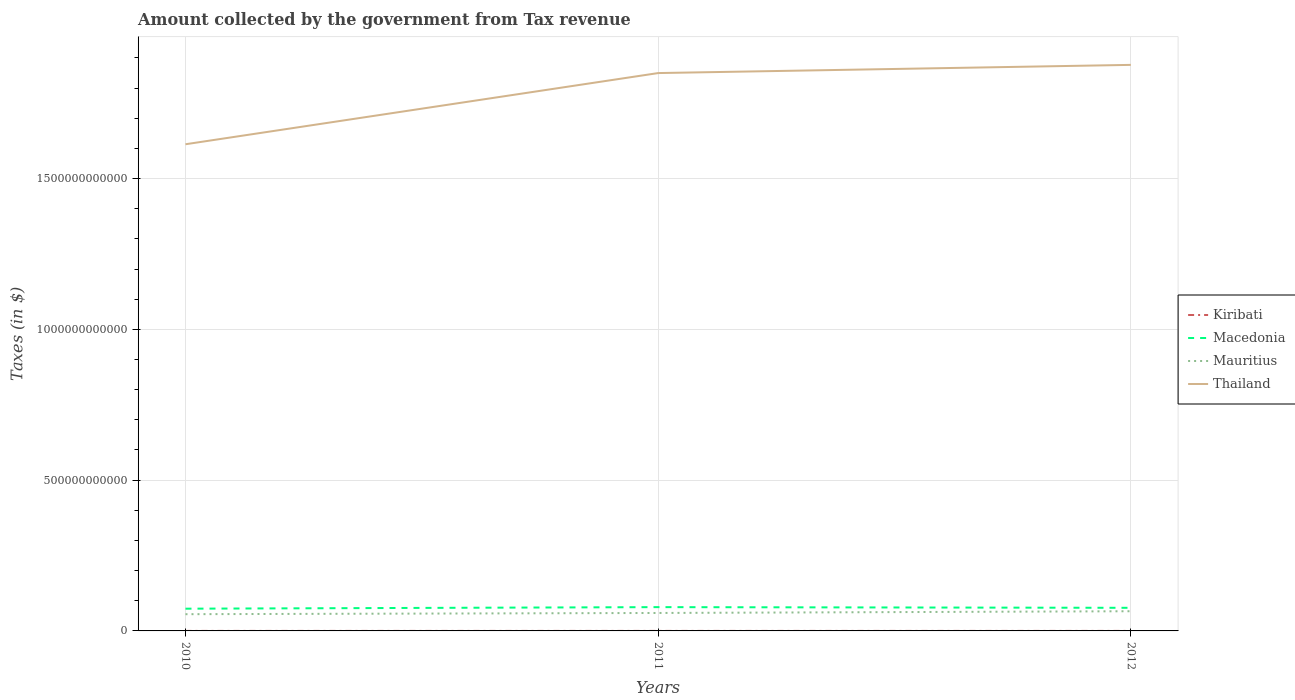How many different coloured lines are there?
Make the answer very short. 4. Does the line corresponding to Kiribati intersect with the line corresponding to Macedonia?
Offer a terse response. No. Is the number of lines equal to the number of legend labels?
Make the answer very short. Yes. Across all years, what is the maximum amount collected by the government from tax revenue in Mauritius?
Your response must be concise. 5.55e+1. What is the total amount collected by the government from tax revenue in Kiribati in the graph?
Keep it short and to the point. -5.32e+05. What is the difference between the highest and the second highest amount collected by the government from tax revenue in Thailand?
Ensure brevity in your answer.  2.63e+11. Is the amount collected by the government from tax revenue in Thailand strictly greater than the amount collected by the government from tax revenue in Macedonia over the years?
Offer a terse response. No. How many years are there in the graph?
Offer a very short reply. 3. What is the difference between two consecutive major ticks on the Y-axis?
Offer a very short reply. 5.00e+11. Are the values on the major ticks of Y-axis written in scientific E-notation?
Your answer should be very brief. No. Does the graph contain any zero values?
Your answer should be compact. No. Where does the legend appear in the graph?
Provide a short and direct response. Center right. How many legend labels are there?
Provide a succinct answer. 4. What is the title of the graph?
Your answer should be very brief. Amount collected by the government from Tax revenue. What is the label or title of the X-axis?
Give a very brief answer. Years. What is the label or title of the Y-axis?
Offer a very short reply. Taxes (in $). What is the Taxes (in $) of Kiribati in 2010?
Keep it short and to the point. 2.67e+07. What is the Taxes (in $) of Macedonia in 2010?
Provide a succinct answer. 7.38e+1. What is the Taxes (in $) of Mauritius in 2010?
Ensure brevity in your answer.  5.55e+1. What is the Taxes (in $) of Thailand in 2010?
Your response must be concise. 1.61e+12. What is the Taxes (in $) of Kiribati in 2011?
Your response must be concise. 2.73e+07. What is the Taxes (in $) in Macedonia in 2011?
Keep it short and to the point. 7.89e+1. What is the Taxes (in $) in Mauritius in 2011?
Make the answer very short. 5.95e+1. What is the Taxes (in $) in Thailand in 2011?
Give a very brief answer. 1.85e+12. What is the Taxes (in $) of Kiribati in 2012?
Give a very brief answer. 2.71e+07. What is the Taxes (in $) in Macedonia in 2012?
Your answer should be compact. 7.66e+1. What is the Taxes (in $) of Mauritius in 2012?
Provide a short and direct response. 6.53e+1. What is the Taxes (in $) in Thailand in 2012?
Keep it short and to the point. 1.88e+12. Across all years, what is the maximum Taxes (in $) in Kiribati?
Ensure brevity in your answer.  2.73e+07. Across all years, what is the maximum Taxes (in $) of Macedonia?
Offer a very short reply. 7.89e+1. Across all years, what is the maximum Taxes (in $) in Mauritius?
Provide a short and direct response. 6.53e+1. Across all years, what is the maximum Taxes (in $) of Thailand?
Keep it short and to the point. 1.88e+12. Across all years, what is the minimum Taxes (in $) of Kiribati?
Give a very brief answer. 2.67e+07. Across all years, what is the minimum Taxes (in $) in Macedonia?
Provide a succinct answer. 7.38e+1. Across all years, what is the minimum Taxes (in $) in Mauritius?
Your answer should be compact. 5.55e+1. Across all years, what is the minimum Taxes (in $) in Thailand?
Make the answer very short. 1.61e+12. What is the total Taxes (in $) of Kiribati in the graph?
Keep it short and to the point. 8.11e+07. What is the total Taxes (in $) in Macedonia in the graph?
Offer a terse response. 2.29e+11. What is the total Taxes (in $) in Mauritius in the graph?
Give a very brief answer. 1.80e+11. What is the total Taxes (in $) of Thailand in the graph?
Ensure brevity in your answer.  5.34e+12. What is the difference between the Taxes (in $) in Kiribati in 2010 and that in 2011?
Your answer should be compact. -5.32e+05. What is the difference between the Taxes (in $) of Macedonia in 2010 and that in 2011?
Offer a very short reply. -5.16e+09. What is the difference between the Taxes (in $) in Mauritius in 2010 and that in 2011?
Your response must be concise. -4.05e+09. What is the difference between the Taxes (in $) in Thailand in 2010 and that in 2011?
Offer a terse response. -2.36e+11. What is the difference between the Taxes (in $) in Kiribati in 2010 and that in 2012?
Offer a very short reply. -3.91e+05. What is the difference between the Taxes (in $) of Macedonia in 2010 and that in 2012?
Your answer should be very brief. -2.86e+09. What is the difference between the Taxes (in $) in Mauritius in 2010 and that in 2012?
Ensure brevity in your answer.  -9.81e+09. What is the difference between the Taxes (in $) in Thailand in 2010 and that in 2012?
Keep it short and to the point. -2.63e+11. What is the difference between the Taxes (in $) of Kiribati in 2011 and that in 2012?
Ensure brevity in your answer.  1.41e+05. What is the difference between the Taxes (in $) in Macedonia in 2011 and that in 2012?
Your answer should be very brief. 2.29e+09. What is the difference between the Taxes (in $) of Mauritius in 2011 and that in 2012?
Provide a short and direct response. -5.76e+09. What is the difference between the Taxes (in $) in Thailand in 2011 and that in 2012?
Your response must be concise. -2.72e+1. What is the difference between the Taxes (in $) of Kiribati in 2010 and the Taxes (in $) of Macedonia in 2011?
Provide a succinct answer. -7.89e+1. What is the difference between the Taxes (in $) of Kiribati in 2010 and the Taxes (in $) of Mauritius in 2011?
Give a very brief answer. -5.95e+1. What is the difference between the Taxes (in $) of Kiribati in 2010 and the Taxes (in $) of Thailand in 2011?
Ensure brevity in your answer.  -1.85e+12. What is the difference between the Taxes (in $) of Macedonia in 2010 and the Taxes (in $) of Mauritius in 2011?
Make the answer very short. 1.42e+1. What is the difference between the Taxes (in $) of Macedonia in 2010 and the Taxes (in $) of Thailand in 2011?
Provide a short and direct response. -1.78e+12. What is the difference between the Taxes (in $) of Mauritius in 2010 and the Taxes (in $) of Thailand in 2011?
Offer a very short reply. -1.79e+12. What is the difference between the Taxes (in $) of Kiribati in 2010 and the Taxes (in $) of Macedonia in 2012?
Provide a succinct answer. -7.66e+1. What is the difference between the Taxes (in $) in Kiribati in 2010 and the Taxes (in $) in Mauritius in 2012?
Your answer should be very brief. -6.53e+1. What is the difference between the Taxes (in $) in Kiribati in 2010 and the Taxes (in $) in Thailand in 2012?
Make the answer very short. -1.88e+12. What is the difference between the Taxes (in $) of Macedonia in 2010 and the Taxes (in $) of Mauritius in 2012?
Make the answer very short. 8.46e+09. What is the difference between the Taxes (in $) in Macedonia in 2010 and the Taxes (in $) in Thailand in 2012?
Offer a terse response. -1.80e+12. What is the difference between the Taxes (in $) of Mauritius in 2010 and the Taxes (in $) of Thailand in 2012?
Keep it short and to the point. -1.82e+12. What is the difference between the Taxes (in $) of Kiribati in 2011 and the Taxes (in $) of Macedonia in 2012?
Provide a short and direct response. -7.66e+1. What is the difference between the Taxes (in $) of Kiribati in 2011 and the Taxes (in $) of Mauritius in 2012?
Ensure brevity in your answer.  -6.53e+1. What is the difference between the Taxes (in $) of Kiribati in 2011 and the Taxes (in $) of Thailand in 2012?
Ensure brevity in your answer.  -1.88e+12. What is the difference between the Taxes (in $) in Macedonia in 2011 and the Taxes (in $) in Mauritius in 2012?
Give a very brief answer. 1.36e+1. What is the difference between the Taxes (in $) of Macedonia in 2011 and the Taxes (in $) of Thailand in 2012?
Offer a very short reply. -1.80e+12. What is the difference between the Taxes (in $) in Mauritius in 2011 and the Taxes (in $) in Thailand in 2012?
Your answer should be compact. -1.82e+12. What is the average Taxes (in $) of Kiribati per year?
Give a very brief answer. 2.70e+07. What is the average Taxes (in $) of Macedonia per year?
Make the answer very short. 7.64e+1. What is the average Taxes (in $) of Mauritius per year?
Your response must be concise. 6.01e+1. What is the average Taxes (in $) of Thailand per year?
Your answer should be compact. 1.78e+12. In the year 2010, what is the difference between the Taxes (in $) in Kiribati and Taxes (in $) in Macedonia?
Your answer should be very brief. -7.37e+1. In the year 2010, what is the difference between the Taxes (in $) of Kiribati and Taxes (in $) of Mauritius?
Ensure brevity in your answer.  -5.55e+1. In the year 2010, what is the difference between the Taxes (in $) of Kiribati and Taxes (in $) of Thailand?
Make the answer very short. -1.61e+12. In the year 2010, what is the difference between the Taxes (in $) of Macedonia and Taxes (in $) of Mauritius?
Offer a very short reply. 1.83e+1. In the year 2010, what is the difference between the Taxes (in $) in Macedonia and Taxes (in $) in Thailand?
Offer a very short reply. -1.54e+12. In the year 2010, what is the difference between the Taxes (in $) in Mauritius and Taxes (in $) in Thailand?
Your answer should be very brief. -1.56e+12. In the year 2011, what is the difference between the Taxes (in $) in Kiribati and Taxes (in $) in Macedonia?
Provide a succinct answer. -7.89e+1. In the year 2011, what is the difference between the Taxes (in $) in Kiribati and Taxes (in $) in Mauritius?
Ensure brevity in your answer.  -5.95e+1. In the year 2011, what is the difference between the Taxes (in $) of Kiribati and Taxes (in $) of Thailand?
Keep it short and to the point. -1.85e+12. In the year 2011, what is the difference between the Taxes (in $) of Macedonia and Taxes (in $) of Mauritius?
Keep it short and to the point. 1.94e+1. In the year 2011, what is the difference between the Taxes (in $) of Macedonia and Taxes (in $) of Thailand?
Make the answer very short. -1.77e+12. In the year 2011, what is the difference between the Taxes (in $) of Mauritius and Taxes (in $) of Thailand?
Give a very brief answer. -1.79e+12. In the year 2012, what is the difference between the Taxes (in $) of Kiribati and Taxes (in $) of Macedonia?
Keep it short and to the point. -7.66e+1. In the year 2012, what is the difference between the Taxes (in $) of Kiribati and Taxes (in $) of Mauritius?
Your response must be concise. -6.53e+1. In the year 2012, what is the difference between the Taxes (in $) of Kiribati and Taxes (in $) of Thailand?
Your response must be concise. -1.88e+12. In the year 2012, what is the difference between the Taxes (in $) in Macedonia and Taxes (in $) in Mauritius?
Give a very brief answer. 1.13e+1. In the year 2012, what is the difference between the Taxes (in $) in Macedonia and Taxes (in $) in Thailand?
Offer a terse response. -1.80e+12. In the year 2012, what is the difference between the Taxes (in $) of Mauritius and Taxes (in $) of Thailand?
Your answer should be very brief. -1.81e+12. What is the ratio of the Taxes (in $) in Kiribati in 2010 to that in 2011?
Offer a terse response. 0.98. What is the ratio of the Taxes (in $) in Macedonia in 2010 to that in 2011?
Give a very brief answer. 0.93. What is the ratio of the Taxes (in $) of Mauritius in 2010 to that in 2011?
Provide a short and direct response. 0.93. What is the ratio of the Taxes (in $) in Thailand in 2010 to that in 2011?
Keep it short and to the point. 0.87. What is the ratio of the Taxes (in $) in Kiribati in 2010 to that in 2012?
Ensure brevity in your answer.  0.99. What is the ratio of the Taxes (in $) of Macedonia in 2010 to that in 2012?
Provide a succinct answer. 0.96. What is the ratio of the Taxes (in $) of Mauritius in 2010 to that in 2012?
Keep it short and to the point. 0.85. What is the ratio of the Taxes (in $) in Thailand in 2010 to that in 2012?
Keep it short and to the point. 0.86. What is the ratio of the Taxes (in $) in Macedonia in 2011 to that in 2012?
Offer a very short reply. 1.03. What is the ratio of the Taxes (in $) in Mauritius in 2011 to that in 2012?
Ensure brevity in your answer.  0.91. What is the ratio of the Taxes (in $) of Thailand in 2011 to that in 2012?
Ensure brevity in your answer.  0.99. What is the difference between the highest and the second highest Taxes (in $) in Kiribati?
Offer a terse response. 1.41e+05. What is the difference between the highest and the second highest Taxes (in $) of Macedonia?
Ensure brevity in your answer.  2.29e+09. What is the difference between the highest and the second highest Taxes (in $) of Mauritius?
Your answer should be very brief. 5.76e+09. What is the difference between the highest and the second highest Taxes (in $) in Thailand?
Your response must be concise. 2.72e+1. What is the difference between the highest and the lowest Taxes (in $) of Kiribati?
Keep it short and to the point. 5.32e+05. What is the difference between the highest and the lowest Taxes (in $) of Macedonia?
Make the answer very short. 5.16e+09. What is the difference between the highest and the lowest Taxes (in $) in Mauritius?
Keep it short and to the point. 9.81e+09. What is the difference between the highest and the lowest Taxes (in $) in Thailand?
Provide a short and direct response. 2.63e+11. 